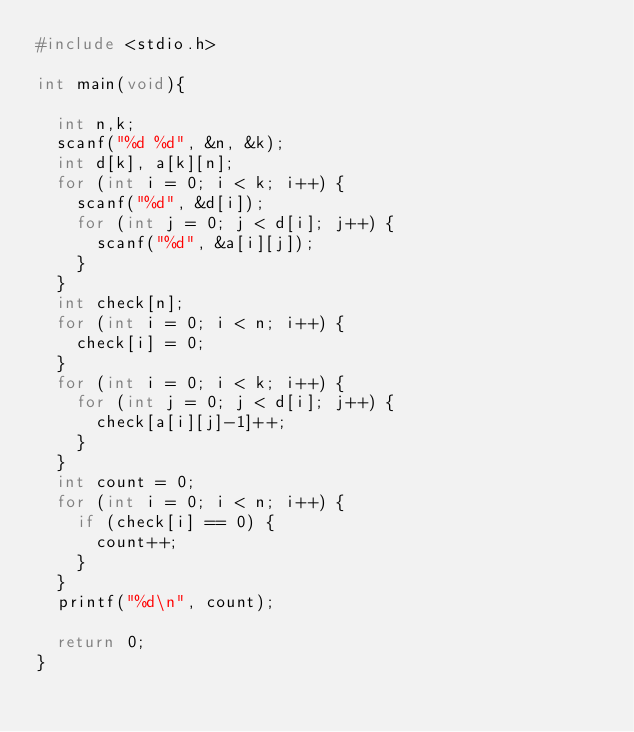<code> <loc_0><loc_0><loc_500><loc_500><_C_>#include <stdio.h>

int main(void){

  int n,k;
  scanf("%d %d", &n, &k);
  int d[k], a[k][n];
  for (int i = 0; i < k; i++) {
    scanf("%d", &d[i]);
    for (int j = 0; j < d[i]; j++) {
      scanf("%d", &a[i][j]);
    }
  }
  int check[n];
  for (int i = 0; i < n; i++) {
    check[i] = 0;
  }
  for (int i = 0; i < k; i++) {
    for (int j = 0; j < d[i]; j++) {
      check[a[i][j]-1]++;
    }
  }
  int count = 0;
  for (int i = 0; i < n; i++) {
    if (check[i] == 0) {
      count++;
    }
  }
  printf("%d\n", count);

  return 0;
}</code> 